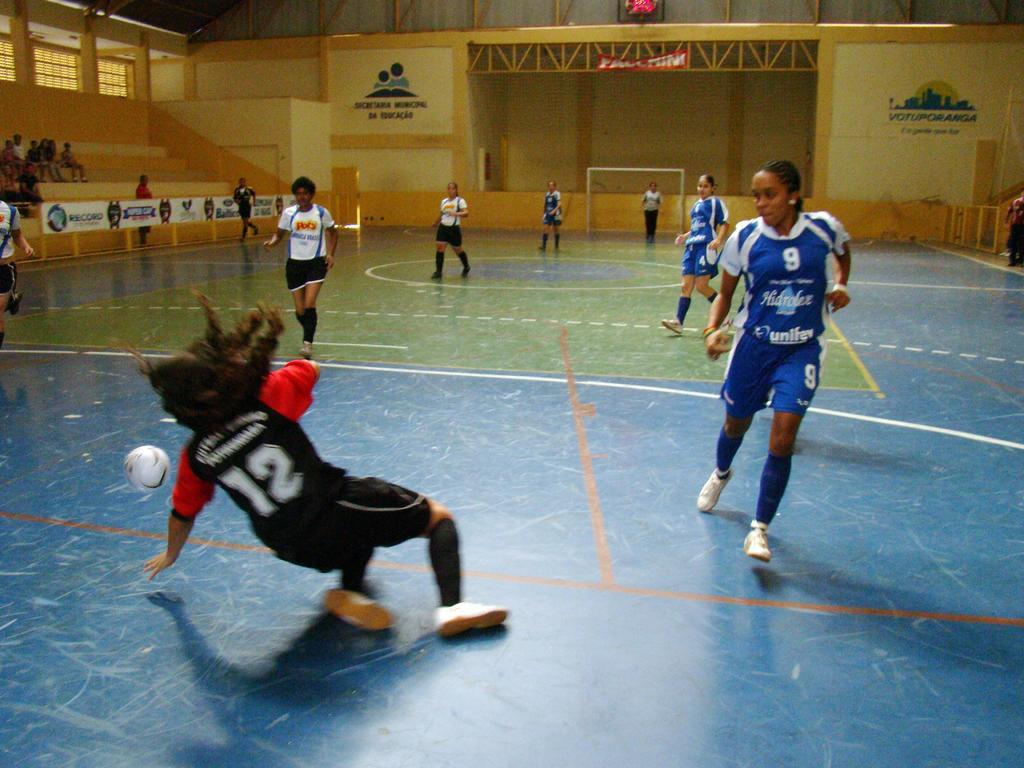What number is the player in black and red?
Make the answer very short. 12. What number is the player in blue wearing?
Your response must be concise. 9. 